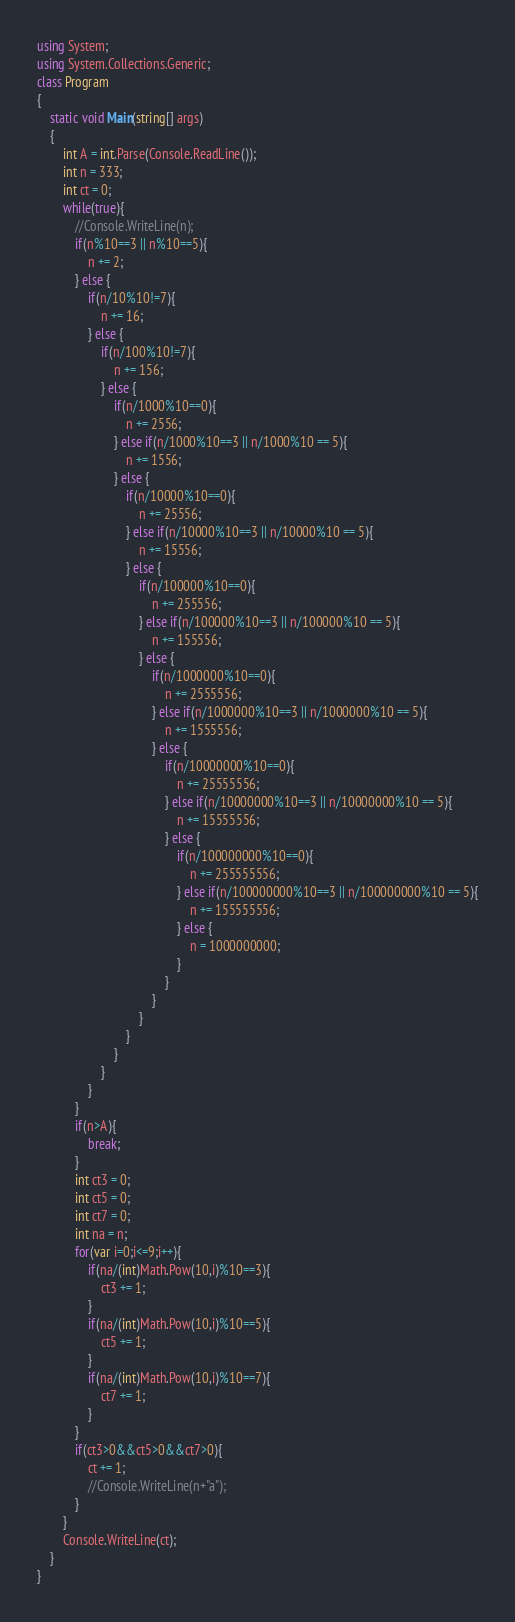<code> <loc_0><loc_0><loc_500><loc_500><_C#_>using System;
using System.Collections.Generic;
class Program
{
	static void Main(string[] args)
	{
		int A = int.Parse(Console.ReadLine());
		int n = 333;
		int ct = 0;
		while(true){
			//Console.WriteLine(n);
			if(n%10==3 || n%10==5){
				n += 2;
			} else {
				if(n/10%10!=7){
					n += 16;
				} else {
					if(n/100%10!=7){
						n += 156;
					} else {
						if(n/1000%10==0){
							n += 2556;
						} else if(n/1000%10==3 || n/1000%10 == 5){
							n += 1556;
						} else {
							if(n/10000%10==0){
								n += 25556;
							} else if(n/10000%10==3 || n/10000%10 == 5){
								n += 15556;
							} else {
								if(n/100000%10==0){
									n += 255556;
								} else if(n/100000%10==3 || n/100000%10 == 5){
									n += 155556;
								} else {
									if(n/1000000%10==0){
										n += 2555556;
									} else if(n/1000000%10==3 || n/1000000%10 == 5){
										n += 1555556;
									} else {
										if(n/10000000%10==0){
											n += 25555556;
										} else if(n/10000000%10==3 || n/10000000%10 == 5){
											n += 15555556;
										} else {
											if(n/100000000%10==0){
												n += 255555556;
											} else if(n/100000000%10==3 || n/100000000%10 == 5){
												n += 155555556;
											} else {
												n = 1000000000;
											}
										}
									}
								}
							}
						}
					}
				}
			}
			if(n>A){
				break;
			}
			int ct3 = 0;
			int ct5 = 0;
			int ct7 = 0;
			int na = n;
			for(var i=0;i<=9;i++){
				if(na/(int)Math.Pow(10,i)%10==3){
					ct3 += 1;
				}
				if(na/(int)Math.Pow(10,i)%10==5){
					ct5 += 1;
				}
				if(na/(int)Math.Pow(10,i)%10==7){
					ct7 += 1;
				}
			}
			if(ct3>0&&ct5>0&&ct7>0){
				ct += 1;
				//Console.WriteLine(n+"a");
			}
		}
		Console.WriteLine(ct);
	}
}</code> 